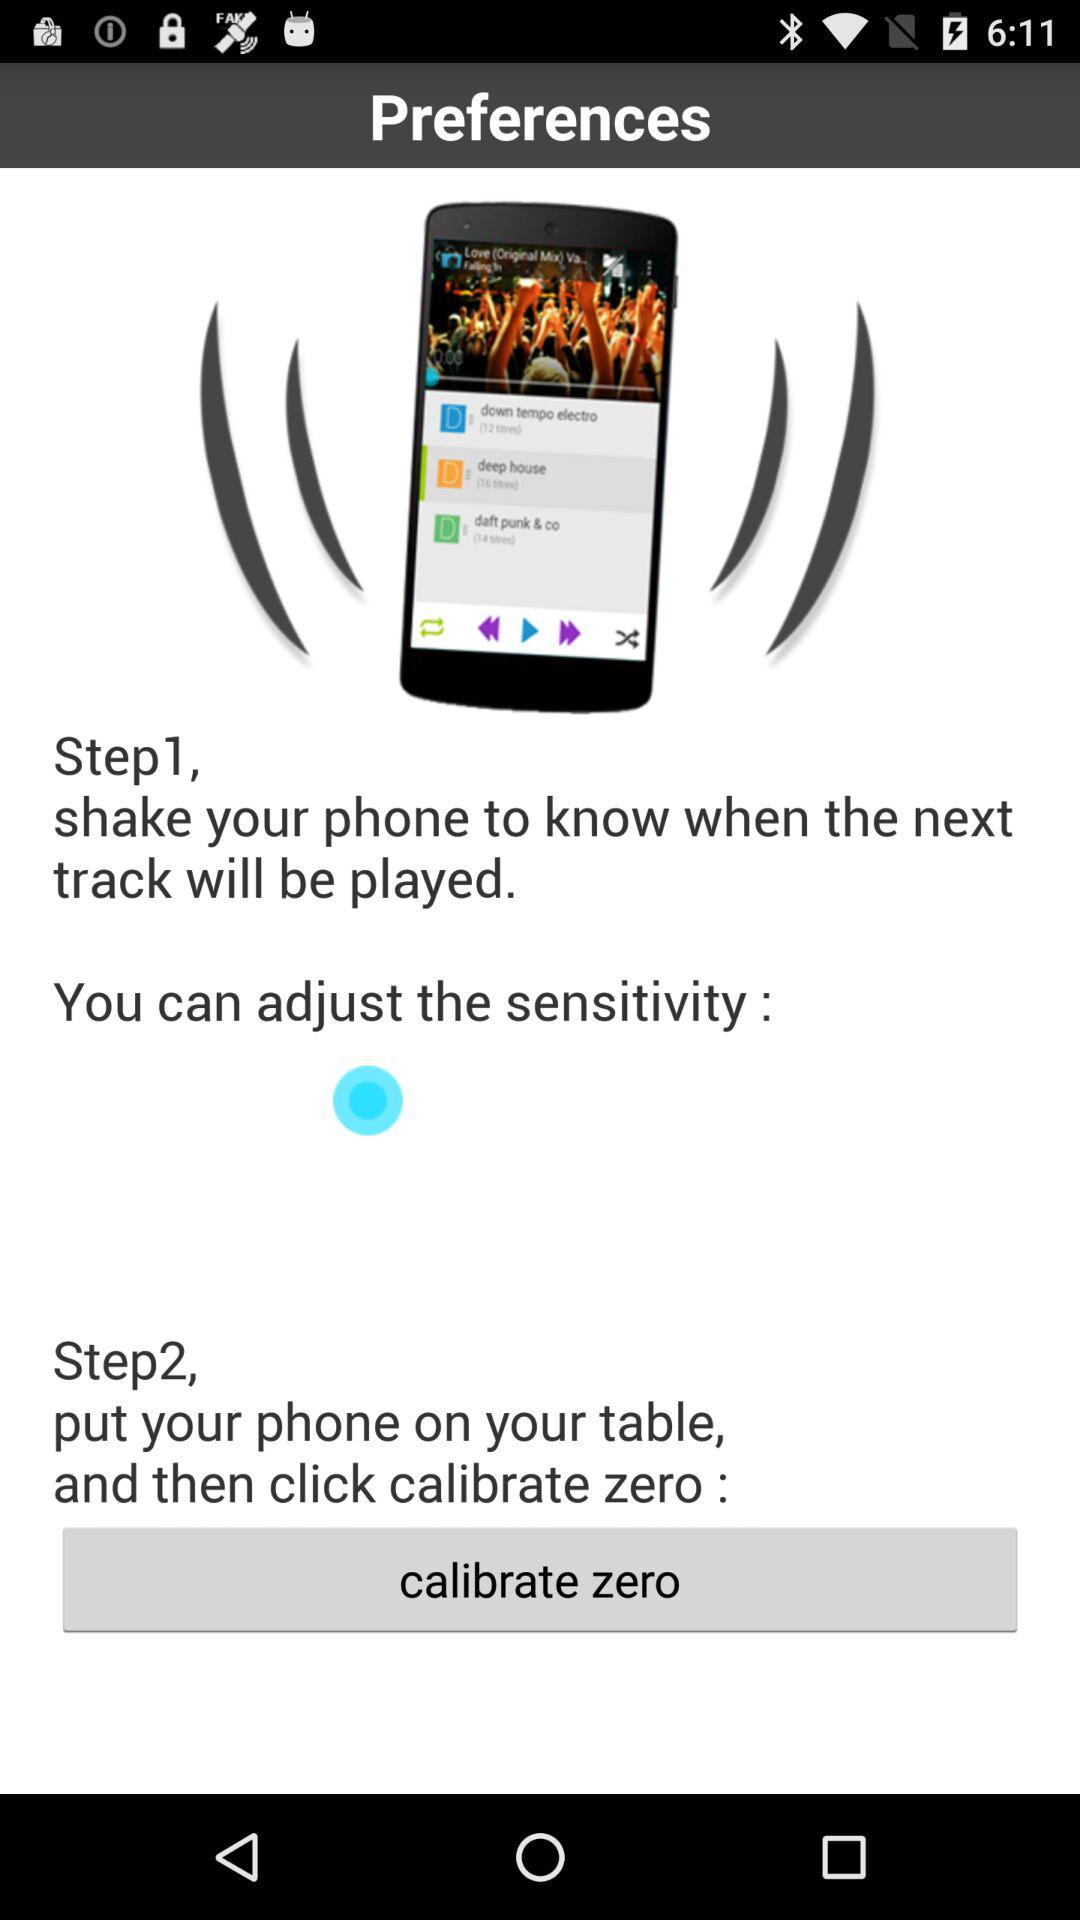How many steps are there in the process?
Answer the question using a single word or phrase. 2 